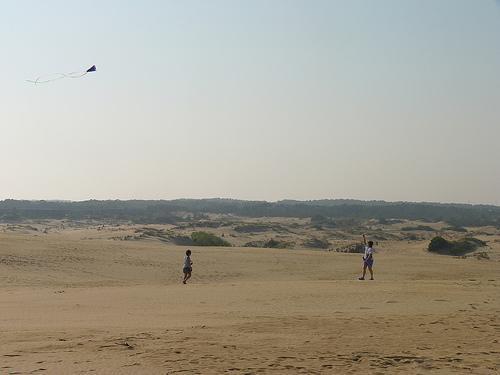How many animals are seen?
Give a very brief answer. 0. 